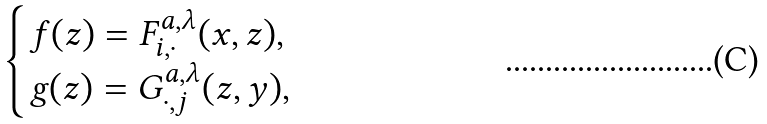<formula> <loc_0><loc_0><loc_500><loc_500>\begin{cases} f ( z ) = F ^ { a , \lambda } _ { i , \cdot } ( x , z ) , \\ g ( z ) = G ^ { a , \lambda } _ { \cdot , j } ( z , y ) , \ \end{cases}</formula> 